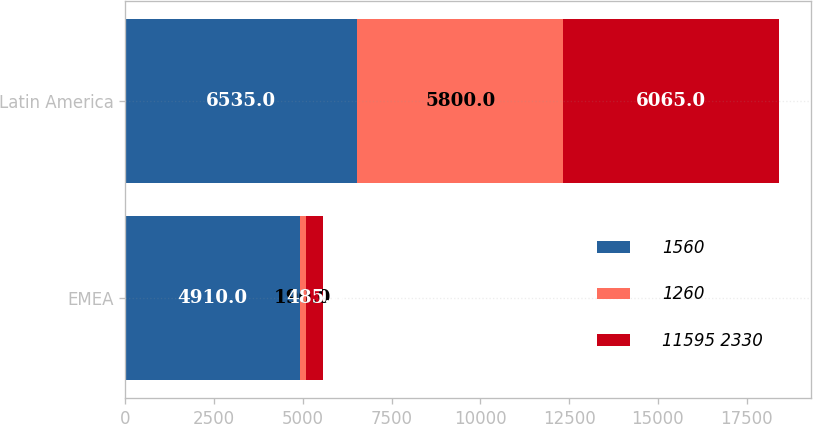Convert chart. <chart><loc_0><loc_0><loc_500><loc_500><stacked_bar_chart><ecel><fcel>EMEA<fcel>Latin America<nl><fcel>1560<fcel>4910<fcel>6535<nl><fcel>1260<fcel>190<fcel>5800<nl><fcel>11595 2330<fcel>485<fcel>6065<nl></chart> 